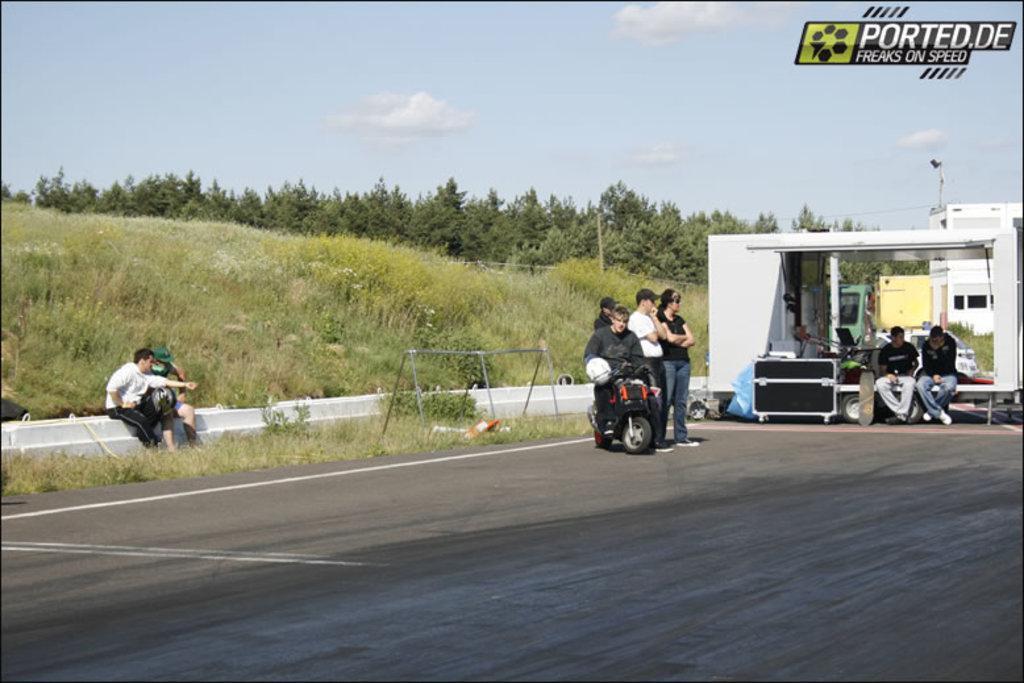Please provide a concise description of this image. Here we can see people, building, box, vehicle and grass. Background there are trees. These are clouds. 